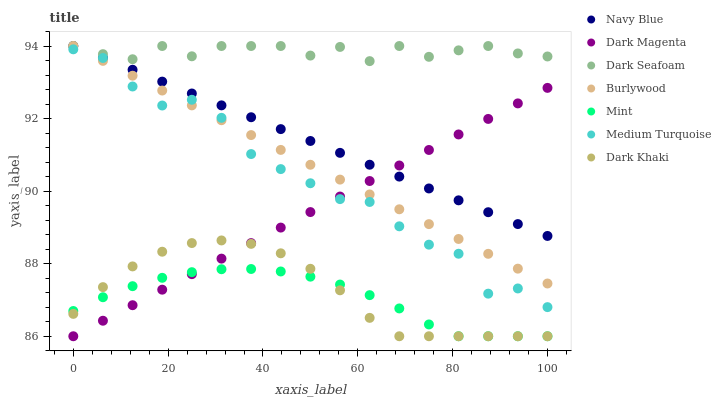Does Mint have the minimum area under the curve?
Answer yes or no. Yes. Does Dark Seafoam have the maximum area under the curve?
Answer yes or no. Yes. Does Burlywood have the minimum area under the curve?
Answer yes or no. No. Does Burlywood have the maximum area under the curve?
Answer yes or no. No. Is Burlywood the smoothest?
Answer yes or no. Yes. Is Medium Turquoise the roughest?
Answer yes or no. Yes. Is Navy Blue the smoothest?
Answer yes or no. No. Is Navy Blue the roughest?
Answer yes or no. No. Does Dark Magenta have the lowest value?
Answer yes or no. Yes. Does Burlywood have the lowest value?
Answer yes or no. No. Does Dark Seafoam have the highest value?
Answer yes or no. Yes. Does Dark Khaki have the highest value?
Answer yes or no. No. Is Medium Turquoise less than Navy Blue?
Answer yes or no. Yes. Is Navy Blue greater than Medium Turquoise?
Answer yes or no. Yes. Does Mint intersect Dark Magenta?
Answer yes or no. Yes. Is Mint less than Dark Magenta?
Answer yes or no. No. Is Mint greater than Dark Magenta?
Answer yes or no. No. Does Medium Turquoise intersect Navy Blue?
Answer yes or no. No. 